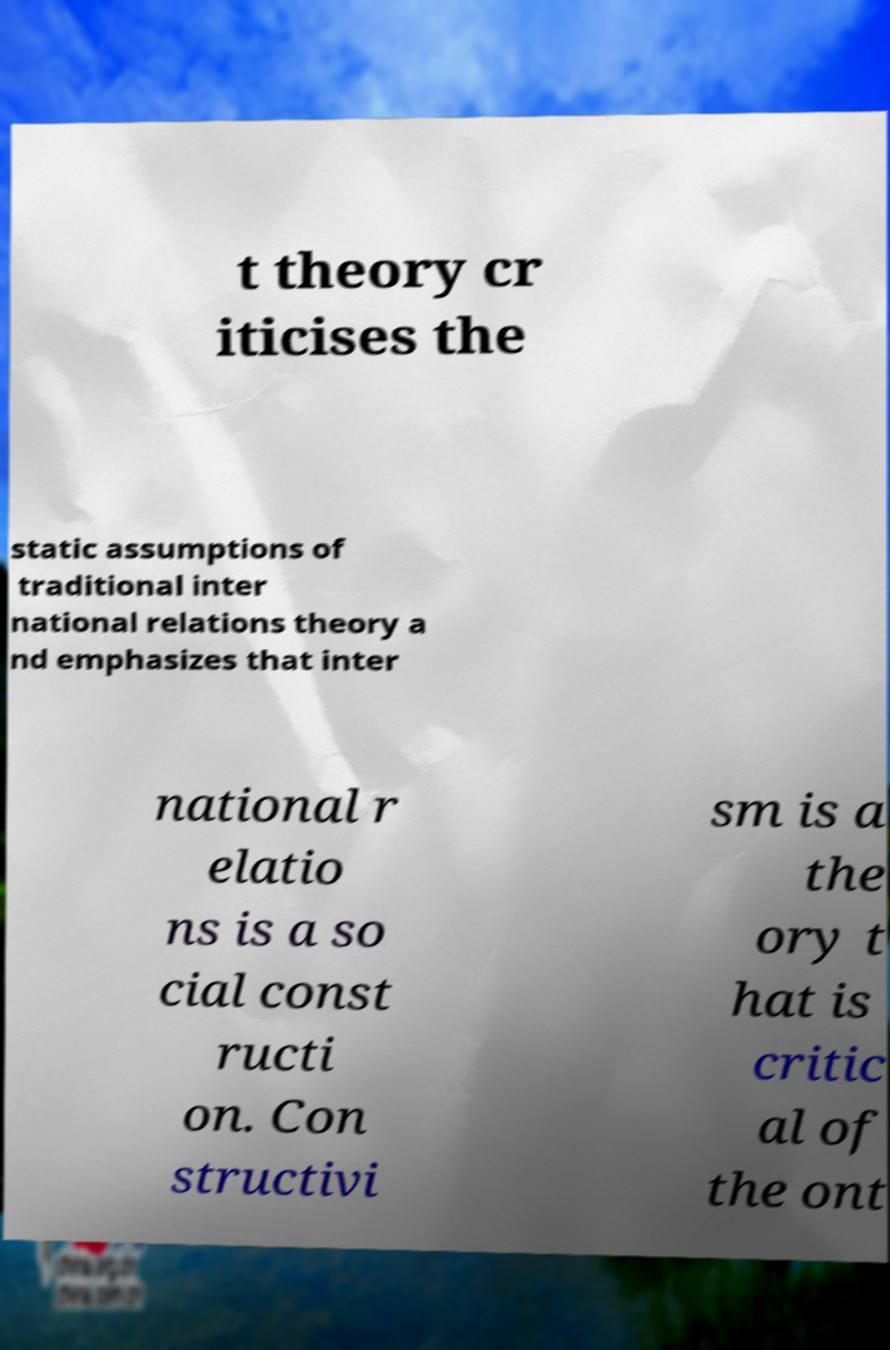I need the written content from this picture converted into text. Can you do that? t theory cr iticises the static assumptions of traditional inter national relations theory a nd emphasizes that inter national r elatio ns is a so cial const ructi on. Con structivi sm is a the ory t hat is critic al of the ont 